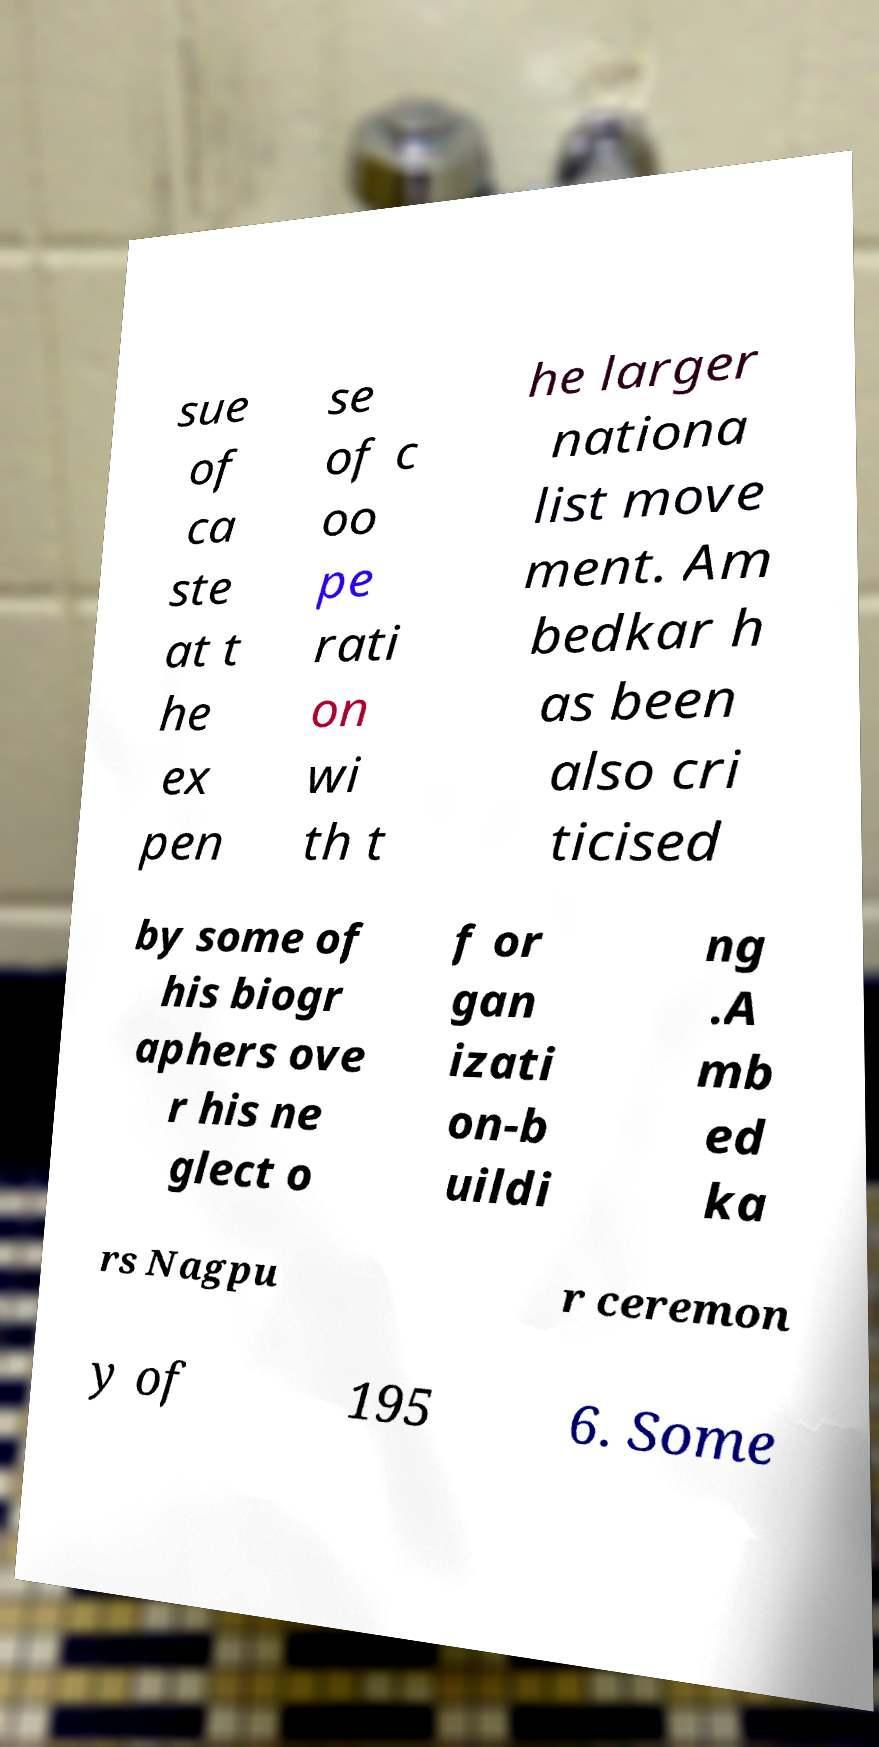Please identify and transcribe the text found in this image. sue of ca ste at t he ex pen se of c oo pe rati on wi th t he larger nationa list move ment. Am bedkar h as been also cri ticised by some of his biogr aphers ove r his ne glect o f or gan izati on-b uildi ng .A mb ed ka rs Nagpu r ceremon y of 195 6. Some 